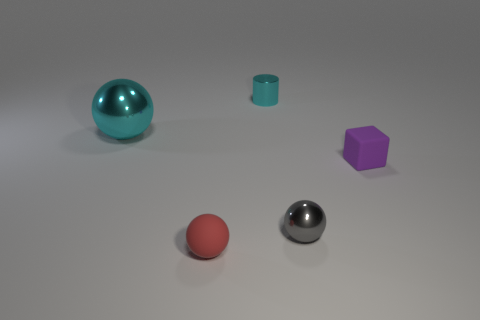Is there anything else that has the same size as the cyan ball?
Keep it short and to the point. No. Does the large cyan object have the same material as the red sphere?
Keep it short and to the point. No. What color is the thing that is both behind the gray shiny ball and on the left side of the tiny shiny cylinder?
Provide a succinct answer. Cyan. There is a shiny sphere on the left side of the cyan shiny cylinder; is it the same color as the small cylinder?
Offer a terse response. Yes. What shape is the cyan thing that is the same size as the cube?
Offer a very short reply. Cylinder. What number of other things are the same color as the large shiny ball?
Give a very brief answer. 1. What number of other objects are there of the same material as the large object?
Your answer should be compact. 2. Do the gray metallic thing and the rubber thing behind the small gray object have the same size?
Your answer should be very brief. Yes. What color is the big metal sphere?
Keep it short and to the point. Cyan. The metal thing that is behind the metal thing that is to the left of the matte object in front of the tiny purple rubber thing is what shape?
Your response must be concise. Cylinder. 